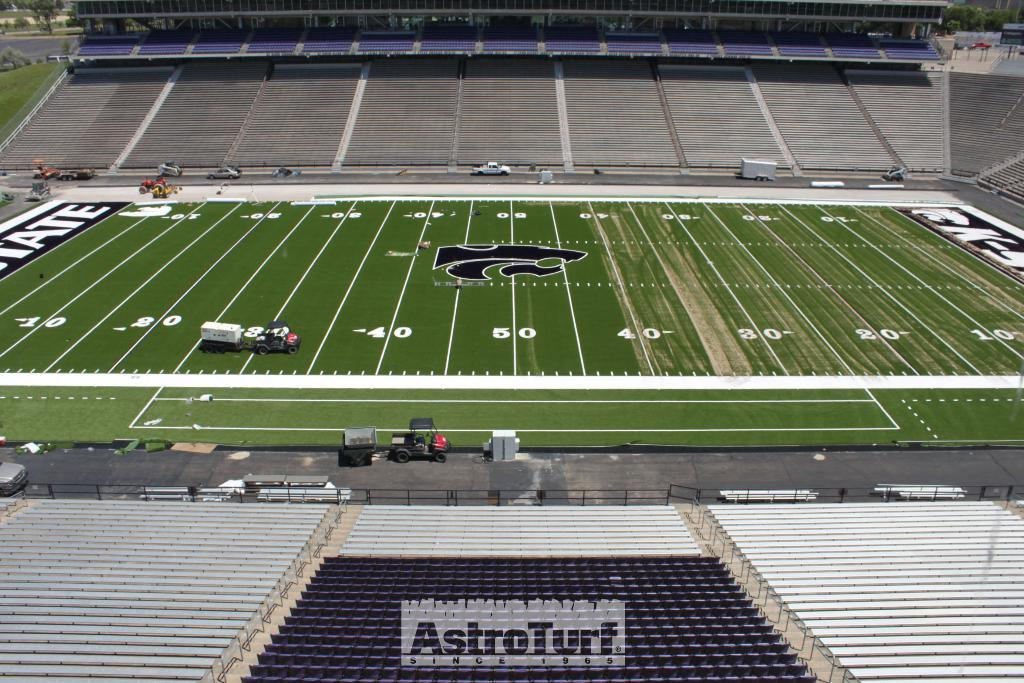<image>
Present a compact description of the photo's key features. football field with bleachers and text saying AstroTurf. 